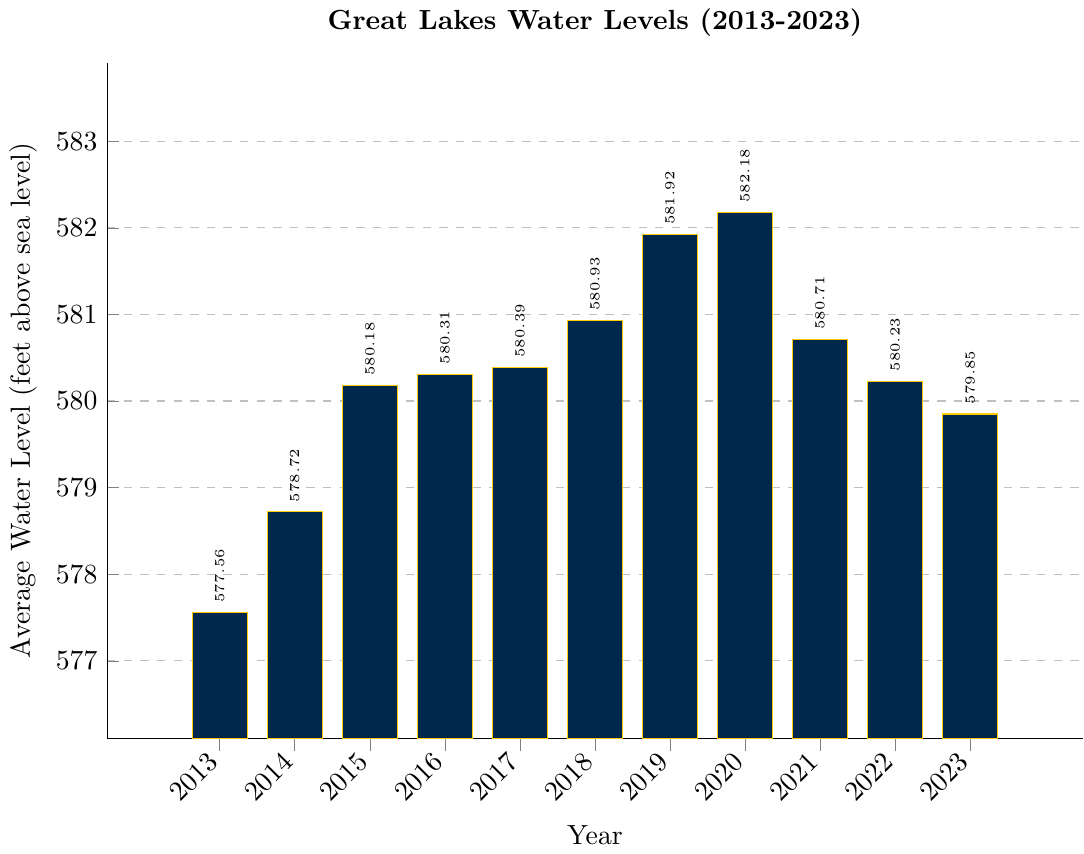What is the highest average water level recorded between 2013 and 2023? In the chart, identify the bar with the highest value. The highest bar represents the average water level in 2020, which is 582.18 feet.
Answer: 582.18 feet How much did the average water level increase from 2013 to 2020? Subtract the 2013 average water level from the 2020 average water level: 582.18 - 577.56 = 4.62 feet.
Answer: 4.62 feet Which year had a lower average water level, 2016 or 2023? Compare the heights of the bars for 2016 and 2023. The 2016 average water level (580.31 feet) is higher than the 2023 average water level (579.85 feet).
Answer: 2023 What is the average water level in 2019 compared to 2018? Compare the heights of the bars for 2019 and 2018. The 2019 average water level (581.92 feet) is higher than the 2018 average water level (580.93 feet).
Answer: 2019 is higher What is the difference in average water levels between the highest and lowest years in the chart? Identify the highest (2020 at 582.18 feet) and lowest (2013 at 577.56 feet) average water levels and subtract the lowest value from the highest: 582.18 - 577.56 = 4.62 feet.
Answer: 4.62 feet During which consecutive years did the average water level remain almost constant? Look for consecutive years where the bars have roughly the same height. Between 2015 and 2017, the average water levels were 580.18, 580.31, and 580.39 feet, which shows small variations.
Answer: 2015-2017 What is the average increase in water level per year from 2013 to 2020? Calculate the total increase from 2013 to 2020 (582.18 - 577.56 = 4.62 feet) and then divide by the number of years (2020-2013 = 7 years): 4.62 / 7 ≈ 0.66 feet per year.
Answer: 0.66 feet per year Did the average water level in 2021 return to the levels seen in 2017? Compare the 2021 and 2017 values. The average water level in 2017 is 580.39 feet and in 2021 is 580.71 feet, indicating that the 2021 levels are slightly higher.
Answer: No, it is higher What is the range of water levels shown in the figure from 2013 to 2023? Calculate the range by subtracting the minimum value (577.56 feet) from the maximum value (582.18 feet): 582.18 - 577.56 = 4.62 feet.
Answer: 4.62 feet 